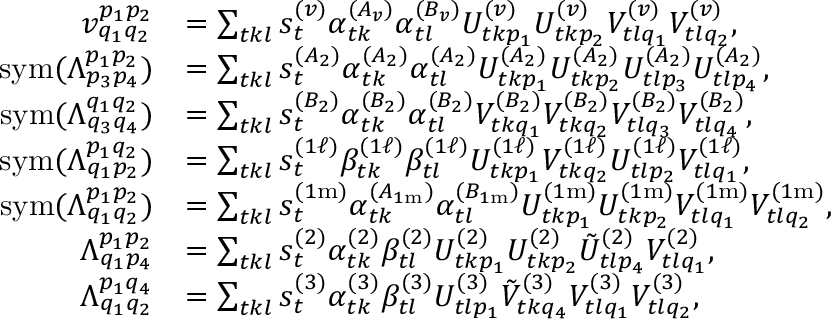Convert formula to latex. <formula><loc_0><loc_0><loc_500><loc_500>\begin{array} { r l } { v _ { q _ { 1 } q _ { 2 } } ^ { p _ { 1 } p _ { 2 } } } & { = \sum _ { t k l } s _ { t } ^ { ( v ) } \alpha _ { t k } ^ { ( A _ { v } ) } \alpha _ { t l } ^ { ( B _ { v } ) } U _ { t k p _ { 1 } } ^ { ( v ) } U _ { t k p _ { 2 } } ^ { ( v ) } V _ { t l q _ { 1 } } ^ { ( v ) } V _ { t l q _ { 2 } } ^ { ( v ) } , } \\ { s y m ( \Lambda _ { p _ { 3 } p _ { 4 } } ^ { p _ { 1 } p _ { 2 } } ) } & { = \sum _ { t k l } s _ { t } ^ { ( A _ { 2 } ) } \alpha _ { t k } ^ { ( A _ { 2 } ) } \alpha _ { t l } ^ { ( A _ { 2 } ) } U _ { t k p _ { 1 } } ^ { ( A _ { 2 } ) } U _ { t k p _ { 2 } } ^ { ( A _ { 2 } ) } U _ { t l p _ { 3 } } ^ { ( A _ { 2 } ) } U _ { t l p _ { 4 } } ^ { ( A _ { 2 } ) } , } \\ { s y m ( \Lambda _ { q _ { 3 } q _ { 4 } } ^ { q _ { 1 } q _ { 2 } } ) } & { = \sum _ { t k l } s _ { t } ^ { ( B _ { 2 } ) } \alpha _ { t k } ^ { ( B _ { 2 } ) } \alpha _ { t l } ^ { ( B _ { 2 } ) } V _ { t k q _ { 1 } } ^ { ( B _ { 2 } ) } V _ { t k q _ { 2 } } ^ { ( B _ { 2 } ) } V _ { t l q _ { 3 } } ^ { ( B _ { 2 } ) } V _ { t l q _ { 4 } } ^ { ( B _ { 2 } ) } , } \\ { s y m ( \Lambda _ { q _ { 1 } p _ { 2 } } ^ { p _ { 1 } q _ { 2 } } ) } & { = \sum _ { t k l } s _ { t } ^ { ( 1 \ell ) } \beta _ { t k } ^ { ( 1 \ell ) } \beta _ { t l } ^ { ( 1 \ell ) } U _ { t k p _ { 1 } } ^ { ( 1 \ell ) } V _ { t k q _ { 2 } } ^ { ( 1 \ell ) } U _ { t l p _ { 2 } } ^ { ( 1 \ell ) } V _ { t l q _ { 1 } } ^ { ( 1 \ell ) } , } \\ { s y m ( \Lambda _ { q _ { 1 } q _ { 2 } } ^ { p _ { 1 } p _ { 2 } } ) } & { = \sum _ { t k l } s _ { t } ^ { ( 1 m ) } \alpha _ { t k } ^ { ( A _ { 1 m } ) } \alpha _ { t l } ^ { ( B _ { 1 m } ) } U _ { t k p _ { 1 } } ^ { ( 1 m ) } U _ { t k p _ { 2 } } ^ { ( 1 m ) } V _ { t l q _ { 1 } } ^ { ( 1 m ) } V _ { t l q _ { 2 } } ^ { ( 1 m ) } , } \\ { \Lambda _ { q _ { 1 } p _ { 4 } } ^ { p _ { 1 } p _ { 2 } } } & { = \sum _ { t k l } s _ { t } ^ { ( 2 ) } \alpha _ { t k } ^ { ( 2 ) } \beta _ { t l } ^ { ( 2 ) } U _ { t k p _ { 1 } } ^ { ( 2 ) } U _ { t k p _ { 2 } } ^ { ( 2 ) } \tilde { U } _ { t l p _ { 4 } } ^ { ( 2 ) } V _ { t l q _ { 1 } } ^ { ( 2 ) } , } \\ { \Lambda _ { q _ { 1 } q _ { 2 } } ^ { p _ { 1 } q _ { 4 } } } & { = \sum _ { t k l } s _ { t } ^ { ( 3 ) } \alpha _ { t k } ^ { ( 3 ) } \beta _ { t l } ^ { ( 3 ) } U _ { t l p _ { 1 } } ^ { ( 3 ) } \tilde { V } _ { t k q _ { 4 } } ^ { ( 3 ) } V _ { t l q _ { 1 } } ^ { ( 3 ) } V _ { t l q _ { 2 } } ^ { ( 3 ) } , } \end{array}</formula> 